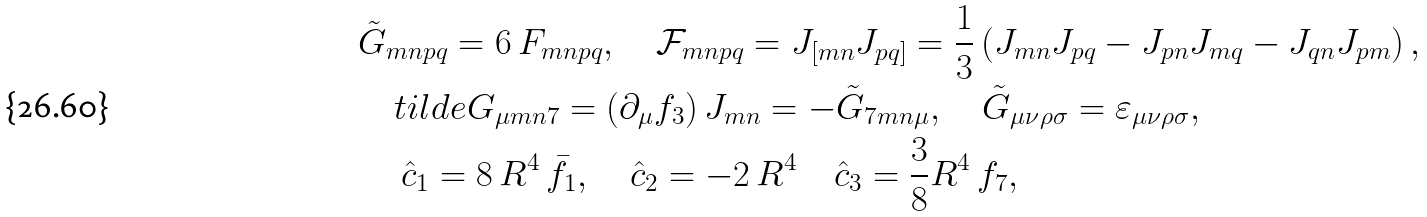<formula> <loc_0><loc_0><loc_500><loc_500>& \tilde { G } _ { m n p q } = 6 \, F _ { m n p q } , \quad \mathcal { F } _ { m n p q } = J _ { [ { m n } } J _ { { p q } ] } = \frac { 1 } { 3 } \left ( J _ { m n } J _ { p q } - J _ { p n } J _ { m q } - J _ { q n } J _ { p m } \right ) , \\ & \quad t i l d e { G } _ { \mu m n 7 } = ( \partial _ { \mu } f _ { 3 } ) \, J _ { m n } = - \tilde { G } _ { 7 m n \mu } , \quad \tilde { G } _ { \mu \nu \rho \sigma } = \varepsilon _ { \mu \nu \rho \sigma } , \\ & \quad \ \hat { c } _ { 1 } = 8 \, R ^ { 4 } \, \bar { f } _ { 1 } , \quad \hat { c } _ { 2 } = - 2 \, R ^ { 4 } \quad \hat { c } _ { 3 } = \frac { 3 } { 8 } R ^ { 4 } \, f _ { 7 } ,</formula> 